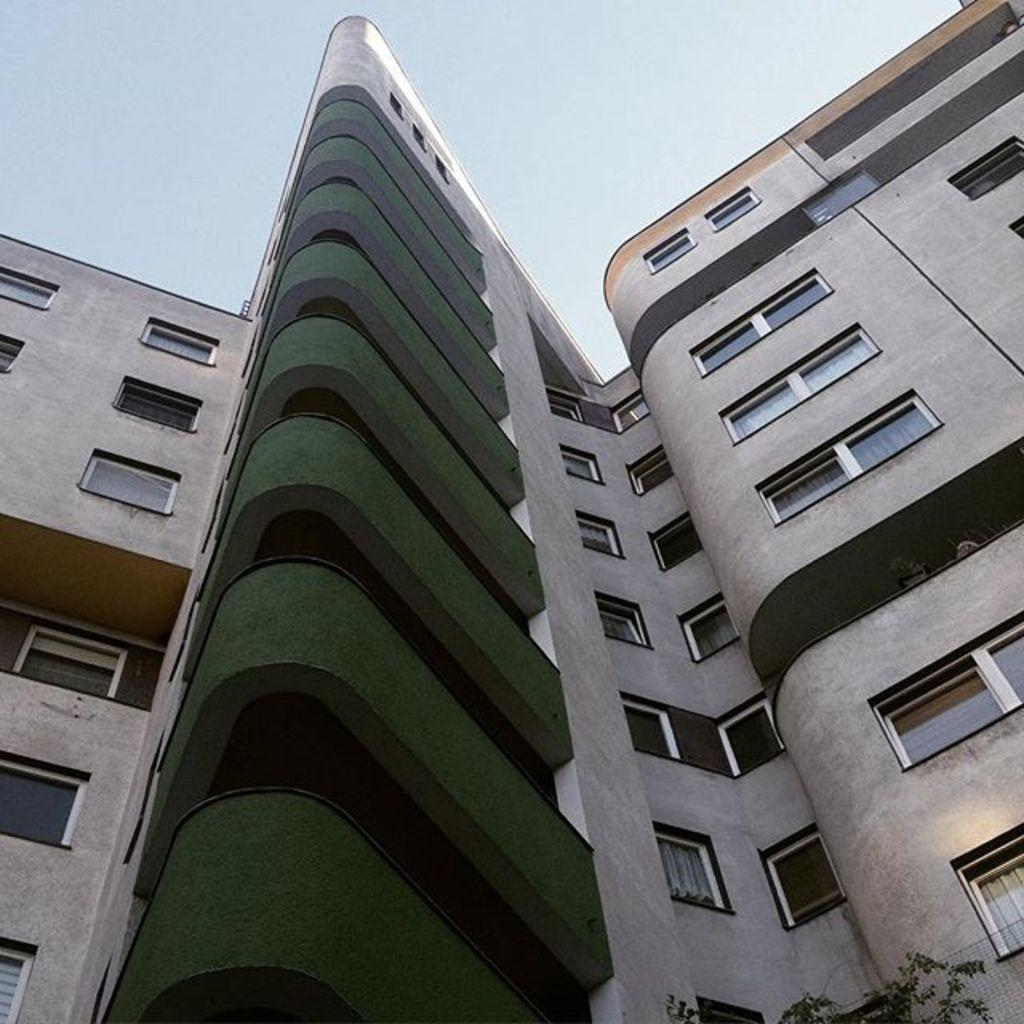What is the main structure in the image? There is a building in the image. What feature can be seen on the building? There are windows on the building. What can be seen in the distance in the image? The sky is visible in the background of the image. What type of lipstick is being applied to the machine in the image? There is no machine or lipstick present in the image; it features a building with windows and a visible sky in the background. 